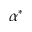<formula> <loc_0><loc_0><loc_500><loc_500>\alpha ^ { * }</formula> 